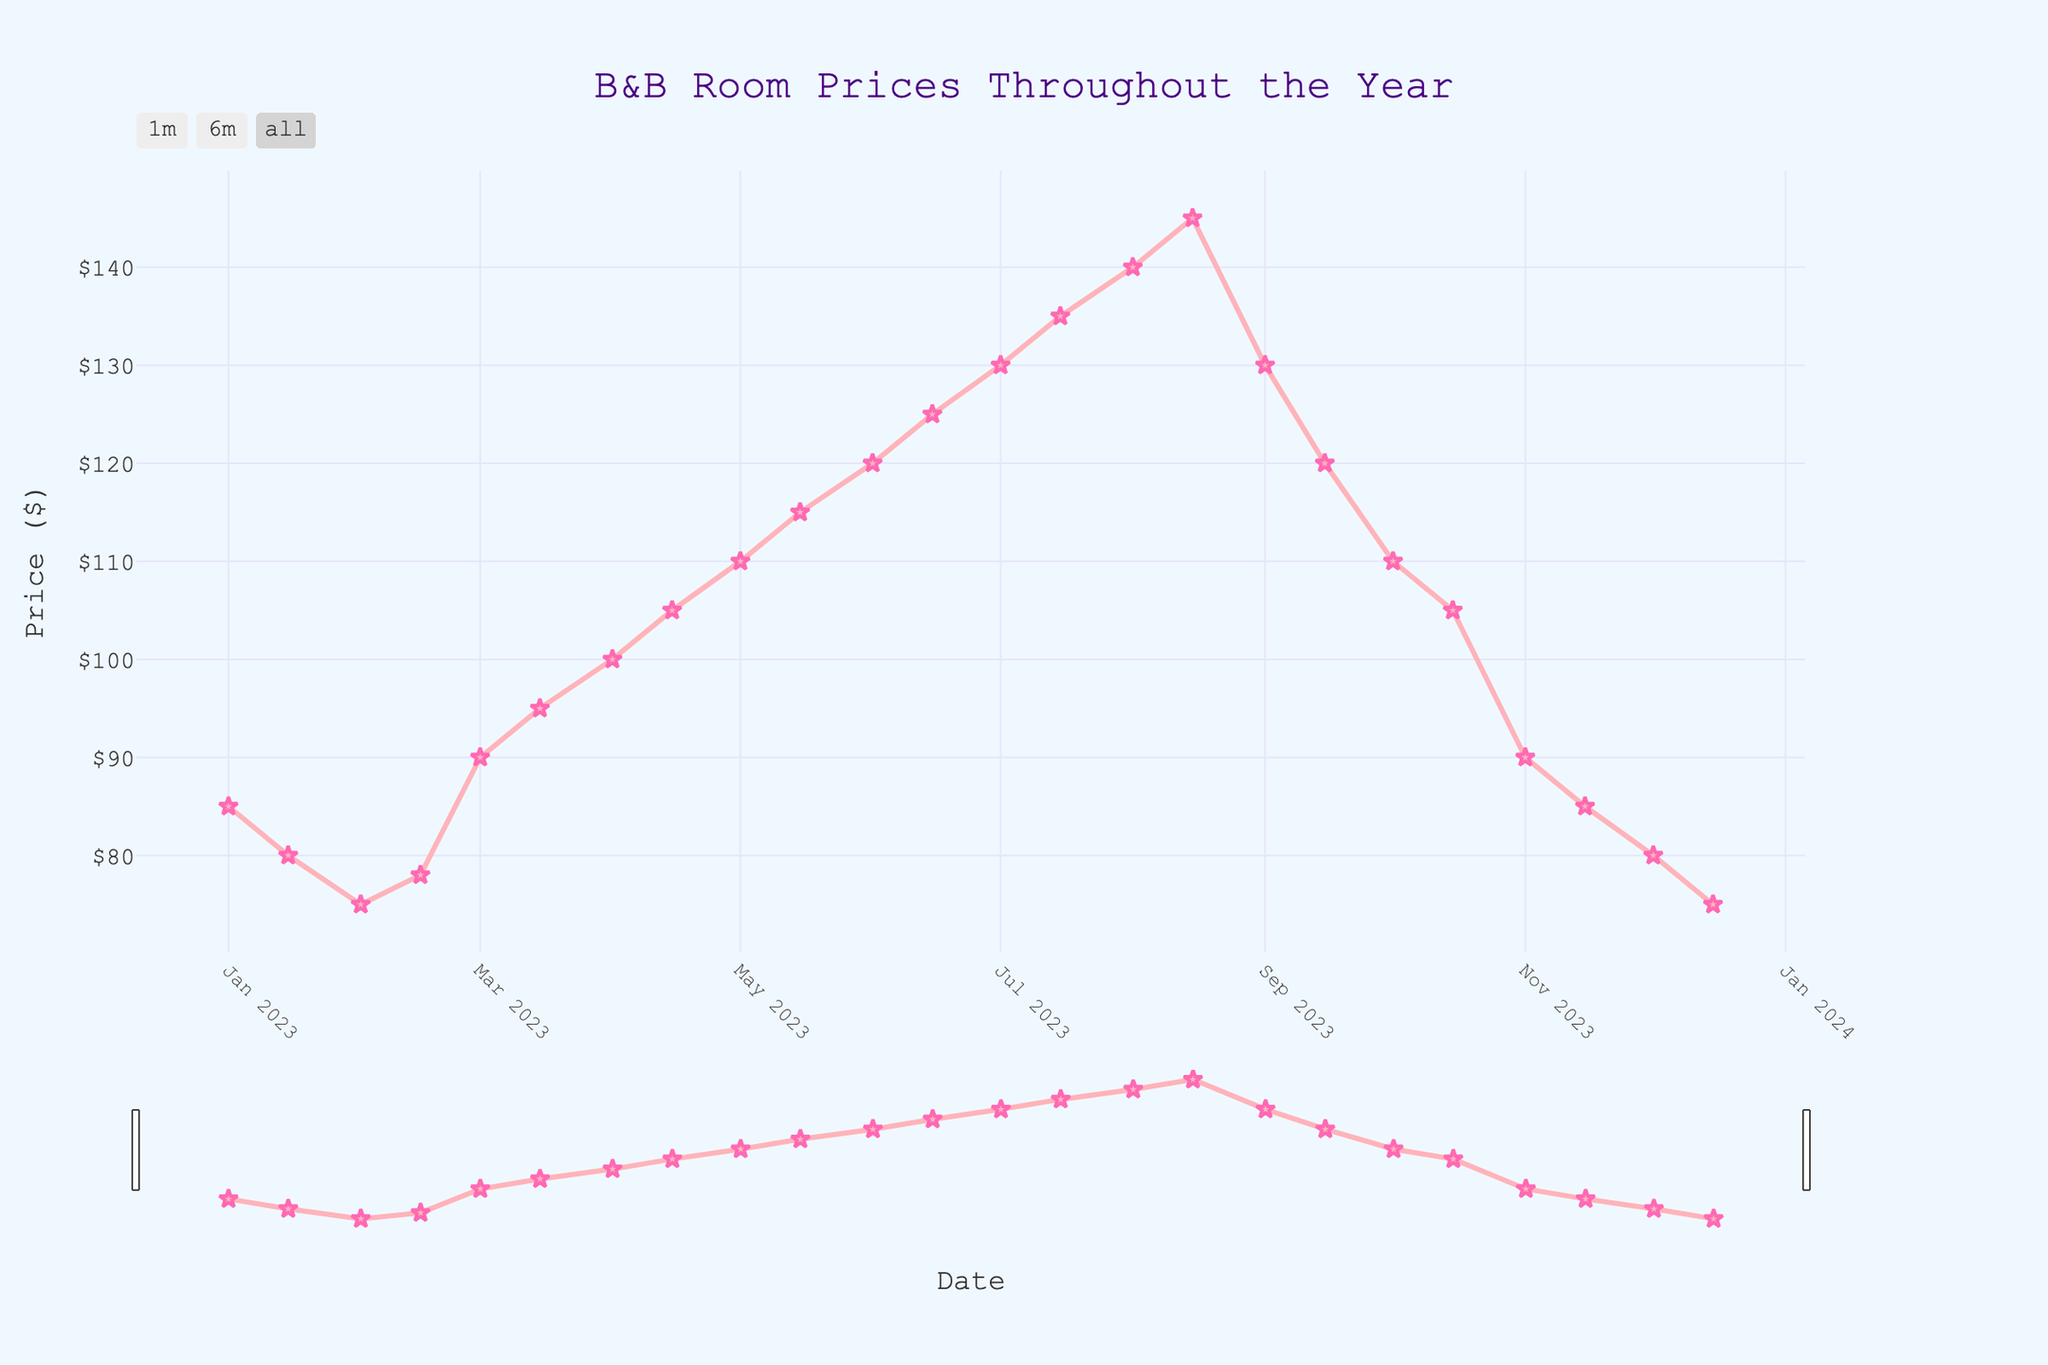When is the peak season for room prices? The peak season for room prices is evident from the figure where the prices are highest. The plot shows that prices climb steadily and peak in mid-August at $145.
Answer: Mid-August Which two months show the fastest increase in prices? To identify the months with the fastest increase, look for the regions on the plot where the slope of the line is steepest. The fastest rise appears between mid-May and mid-July, where prices go from $115 to $135.
Answer: Mid-May to Mid-July What is the lowest nightly price for a room, and when does it occur? The lowest nightly price is the minimum point on the price line in the plot. This occurs at two points: early February and mid-December, both at $75.
Answer: Early February and Mid-December How much do the room prices increase from March to August? To find the price increase, subtract the price at the start of March from the price at the peak in August. The price rises from $90 to $145. The increase is $145 - $90.
Answer: $55 What is the average nightly price in July? The average price for July can be determined by taking the values for early and mid-July and averaging them. The values are $130 and $135. The average is ($130 + $135) / 2.
Answer: $132.5 When do prices start to drop after the summer peak? To determine when prices begin to drop, observe the plot after the peak in August. The first noticeable drop starts in early September, from $145 down to $130.
Answer: Early September Compare the room prices between the start of the year (January) and the end of the year (December). To compare these prices, check the values at the beginning of January and towards the end of December. In January, prices start at $85, and in mid-December, they drop to $75.
Answer: January is higher What is the trend in pricing throughout the year? To identify the overall trend, observe the directional movement of the plot. The prices generally increase from the start of the year until mid-August and then decline towards the year-end.
Answer: Increase then decrease What are the highest and lowest monthly average prices, and in which months do they occur? To find these averages, check the peak and trough points and their corresponding months. The highest average occurs in August ($142.5), and the lowest in December ($77.5).
Answer: August and December 